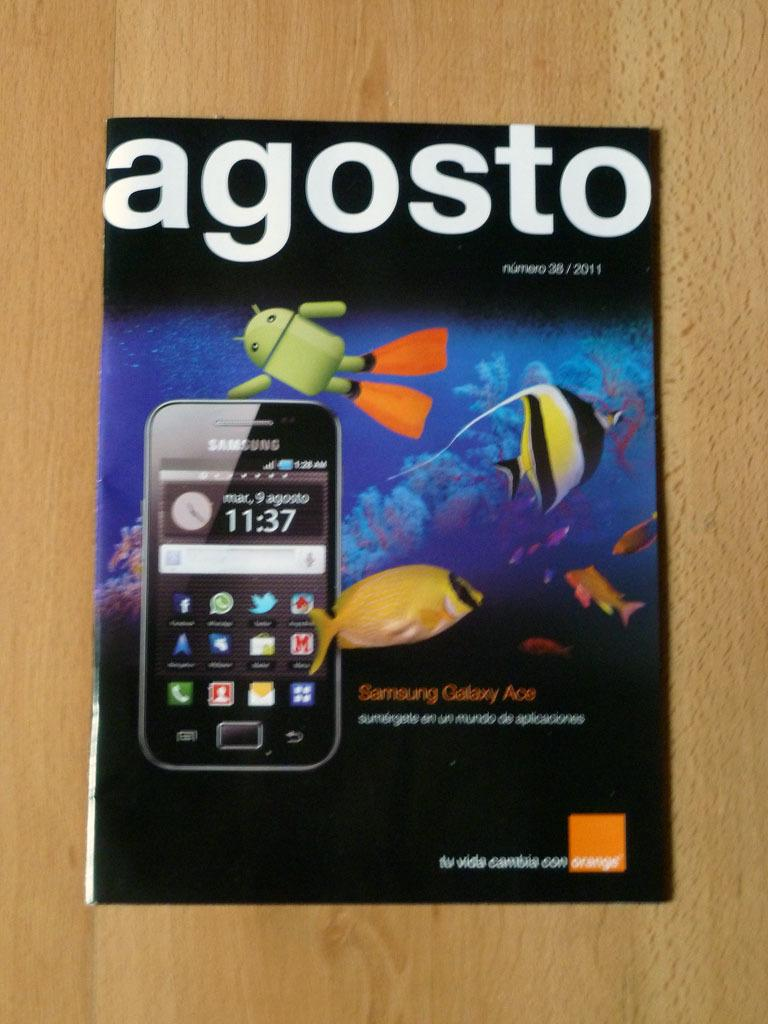<image>
Relay a brief, clear account of the picture shown. A magazine cover entitled agosto with a fish and a Samsung on it. 